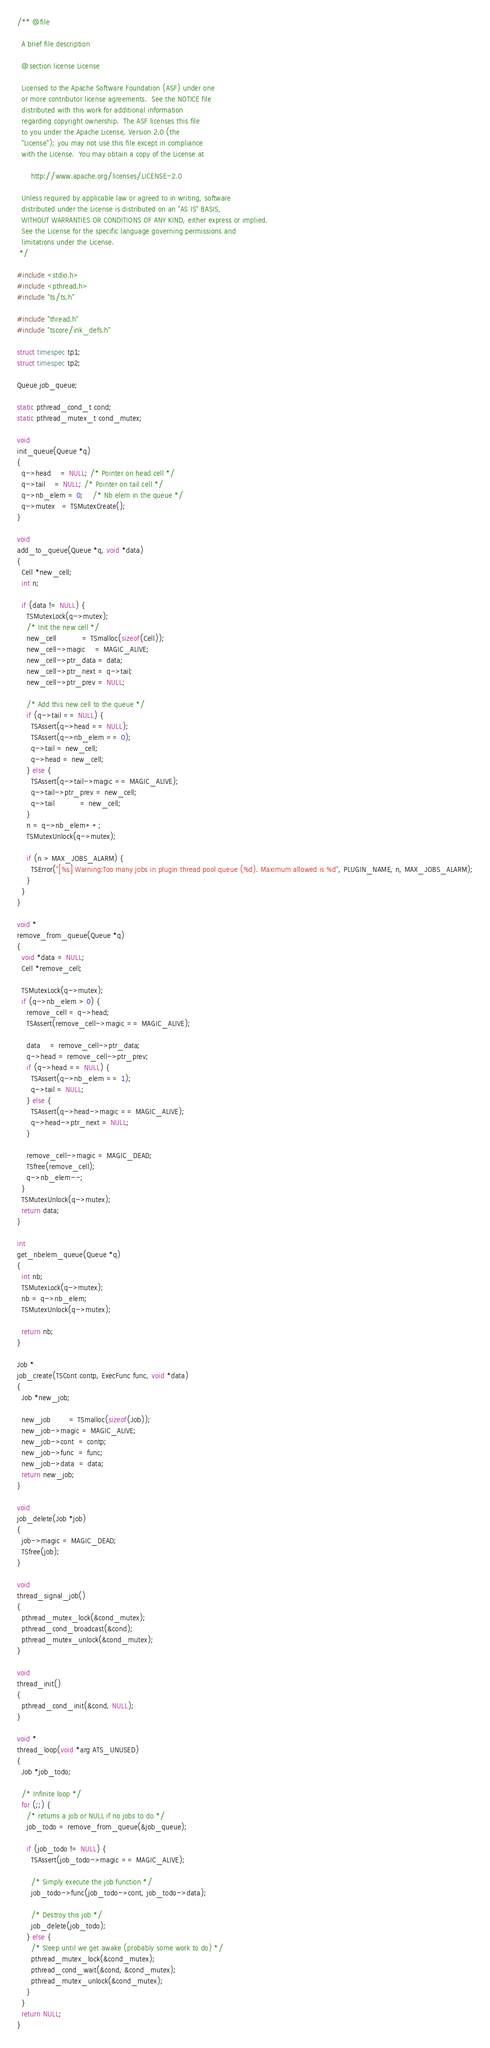Convert code to text. <code><loc_0><loc_0><loc_500><loc_500><_C_>/** @file

  A brief file description

  @section license License

  Licensed to the Apache Software Foundation (ASF) under one
  or more contributor license agreements.  See the NOTICE file
  distributed with this work for additional information
  regarding copyright ownership.  The ASF licenses this file
  to you under the Apache License, Version 2.0 (the
  "License"); you may not use this file except in compliance
  with the License.  You may obtain a copy of the License at

      http://www.apache.org/licenses/LICENSE-2.0

  Unless required by applicable law or agreed to in writing, software
  distributed under the License is distributed on an "AS IS" BASIS,
  WITHOUT WARRANTIES OR CONDITIONS OF ANY KIND, either express or implied.
  See the License for the specific language governing permissions and
  limitations under the License.
 */

#include <stdio.h>
#include <pthread.h>
#include "ts/ts.h"

#include "thread.h"
#include "tscore/ink_defs.h"

struct timespec tp1;
struct timespec tp2;

Queue job_queue;

static pthread_cond_t cond;
static pthread_mutex_t cond_mutex;

void
init_queue(Queue *q)
{
  q->head    = NULL; /* Pointer on head cell */
  q->tail    = NULL; /* Pointer on tail cell */
  q->nb_elem = 0;    /* Nb elem in the queue */
  q->mutex   = TSMutexCreate();
}

void
add_to_queue(Queue *q, void *data)
{
  Cell *new_cell;
  int n;

  if (data != NULL) {
    TSMutexLock(q->mutex);
    /* Init the new cell */
    new_cell           = TSmalloc(sizeof(Cell));
    new_cell->magic    = MAGIC_ALIVE;
    new_cell->ptr_data = data;
    new_cell->ptr_next = q->tail;
    new_cell->ptr_prev = NULL;

    /* Add this new cell to the queue */
    if (q->tail == NULL) {
      TSAssert(q->head == NULL);
      TSAssert(q->nb_elem == 0);
      q->tail = new_cell;
      q->head = new_cell;
    } else {
      TSAssert(q->tail->magic == MAGIC_ALIVE);
      q->tail->ptr_prev = new_cell;
      q->tail           = new_cell;
    }
    n = q->nb_elem++;
    TSMutexUnlock(q->mutex);

    if (n > MAX_JOBS_ALARM) {
      TSError("[%s] Warning:Too many jobs in plugin thread pool queue (%d). Maximum allowed is %d", PLUGIN_NAME, n, MAX_JOBS_ALARM);
    }
  }
}

void *
remove_from_queue(Queue *q)
{
  void *data = NULL;
  Cell *remove_cell;

  TSMutexLock(q->mutex);
  if (q->nb_elem > 0) {
    remove_cell = q->head;
    TSAssert(remove_cell->magic == MAGIC_ALIVE);

    data    = remove_cell->ptr_data;
    q->head = remove_cell->ptr_prev;
    if (q->head == NULL) {
      TSAssert(q->nb_elem == 1);
      q->tail = NULL;
    } else {
      TSAssert(q->head->magic == MAGIC_ALIVE);
      q->head->ptr_next = NULL;
    }

    remove_cell->magic = MAGIC_DEAD;
    TSfree(remove_cell);
    q->nb_elem--;
  }
  TSMutexUnlock(q->mutex);
  return data;
}

int
get_nbelem_queue(Queue *q)
{
  int nb;
  TSMutexLock(q->mutex);
  nb = q->nb_elem;
  TSMutexUnlock(q->mutex);

  return nb;
}

Job *
job_create(TSCont contp, ExecFunc func, void *data)
{
  Job *new_job;

  new_job        = TSmalloc(sizeof(Job));
  new_job->magic = MAGIC_ALIVE;
  new_job->cont  = contp;
  new_job->func  = func;
  new_job->data  = data;
  return new_job;
}

void
job_delete(Job *job)
{
  job->magic = MAGIC_DEAD;
  TSfree(job);
}

void
thread_signal_job()
{
  pthread_mutex_lock(&cond_mutex);
  pthread_cond_broadcast(&cond);
  pthread_mutex_unlock(&cond_mutex);
}

void
thread_init()
{
  pthread_cond_init(&cond, NULL);
}

void *
thread_loop(void *arg ATS_UNUSED)
{
  Job *job_todo;

  /* Infinite loop */
  for (;;) {
    /* returns a job or NULL if no jobs to do */
    job_todo = remove_from_queue(&job_queue);

    if (job_todo != NULL) {
      TSAssert(job_todo->magic == MAGIC_ALIVE);

      /* Simply execute the job function */
      job_todo->func(job_todo->cont, job_todo->data);

      /* Destroy this job */
      job_delete(job_todo);
    } else {
      /* Sleep until we get awake (probably some work to do) */
      pthread_mutex_lock(&cond_mutex);
      pthread_cond_wait(&cond, &cond_mutex);
      pthread_mutex_unlock(&cond_mutex);
    }
  }
  return NULL;
}
</code> 